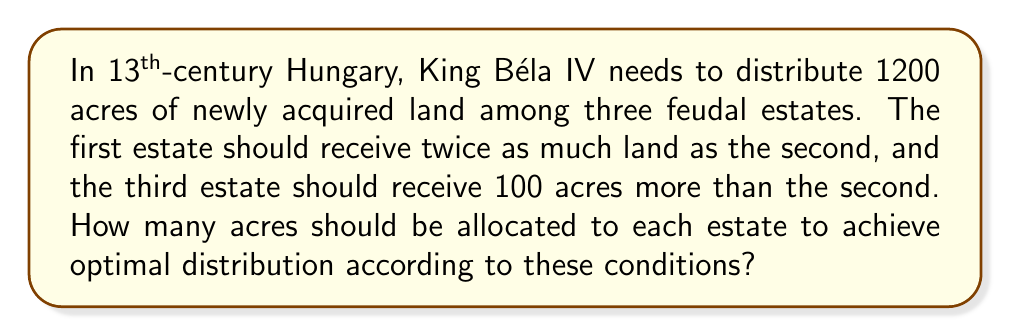Can you solve this math problem? Let's approach this step-by-step:

1) Let $x$ represent the number of acres allocated to the second estate.

2) Given the conditions:
   - First estate: $2x$ acres
   - Second estate: $x$ acres
   - Third estate: $x + 100$ acres

3) The total land to be distributed is 1200 acres, so we can set up the equation:

   $$2x + x + (x + 100) = 1200$$

4) Simplify the left side of the equation:

   $$4x + 100 = 1200$$

5) Subtract 100 from both sides:

   $$4x = 1100$$

6) Divide both sides by 4:

   $$x = 275$$

7) Now we can calculate the acres for each estate:
   - Second estate: $x = 275$ acres
   - First estate: $2x = 2(275) = 550$ acres
   - Third estate: $x + 100 = 275 + 100 = 375$ acres

8) Verify: $550 + 275 + 375 = 1200$ acres (total)
Answer: First estate: 550 acres, Second estate: 275 acres, Third estate: 375 acres 